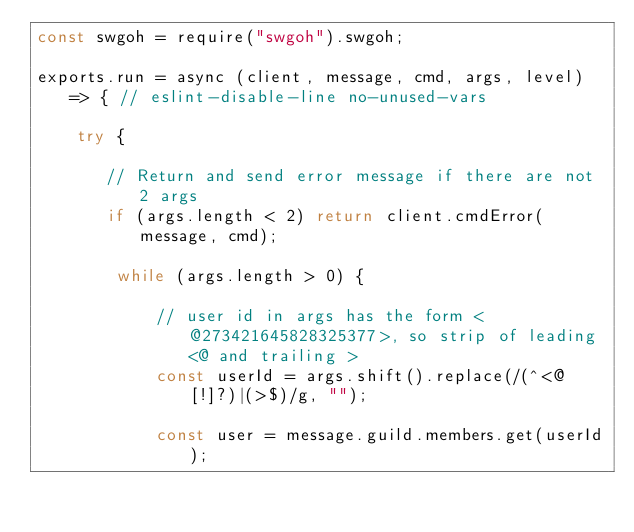Convert code to text. <code><loc_0><loc_0><loc_500><loc_500><_JavaScript_>const swgoh = require("swgoh").swgoh;

exports.run = async (client, message, cmd, args, level) => { // eslint-disable-line no-unused-vars

    try {

       // Return and send error message if there are not 2 args
       if (args.length < 2) return client.cmdError(message, cmd);

        while (args.length > 0) {

            // user id in args has the form <@273421645828325377>, so strip of leading <@ and trailing >
            const userId = args.shift().replace(/(^<@[!]?)|(>$)/g, "");

            const user = message.guild.members.get(userId);</code> 